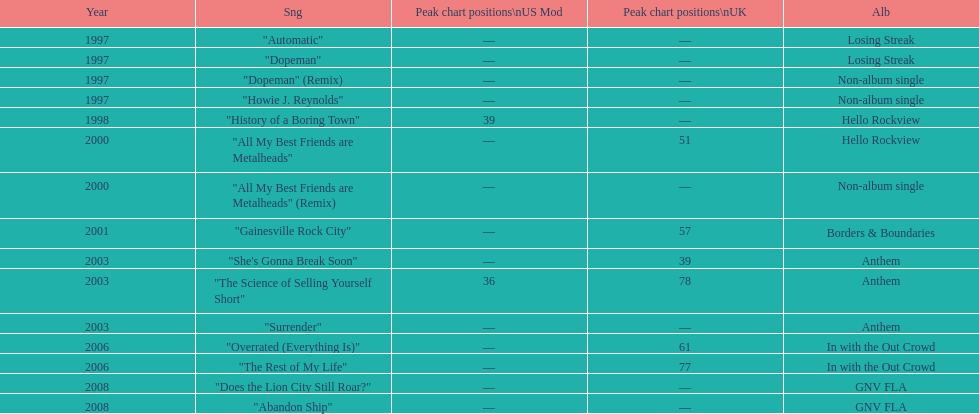Write the full table. {'header': ['Year', 'Sng', 'Peak chart positions\\nUS Mod', 'Peak chart positions\\nUK', 'Alb'], 'rows': [['1997', '"Automatic"', '—', '—', 'Losing Streak'], ['1997', '"Dopeman"', '—', '—', 'Losing Streak'], ['1997', '"Dopeman" (Remix)', '—', '—', 'Non-album single'], ['1997', '"Howie J. Reynolds"', '—', '—', 'Non-album single'], ['1998', '"History of a Boring Town"', '39', '—', 'Hello Rockview'], ['2000', '"All My Best Friends are Metalheads"', '—', '51', 'Hello Rockview'], ['2000', '"All My Best Friends are Metalheads" (Remix)', '—', '—', 'Non-album single'], ['2001', '"Gainesville Rock City"', '—', '57', 'Borders & Boundaries'], ['2003', '"She\'s Gonna Break Soon"', '—', '39', 'Anthem'], ['2003', '"The Science of Selling Yourself Short"', '36', '78', 'Anthem'], ['2003', '"Surrender"', '—', '—', 'Anthem'], ['2006', '"Overrated (Everything Is)"', '—', '61', 'In with the Out Crowd'], ['2006', '"The Rest of My Life"', '—', '77', 'In with the Out Crowd'], ['2008', '"Does the Lion City Still Roar?"', '—', '—', 'GNV FLA'], ['2008', '"Abandon Ship"', '—', '—', 'GNV FLA']]} What was the average chart position of their singles in the uk? 60.5. 